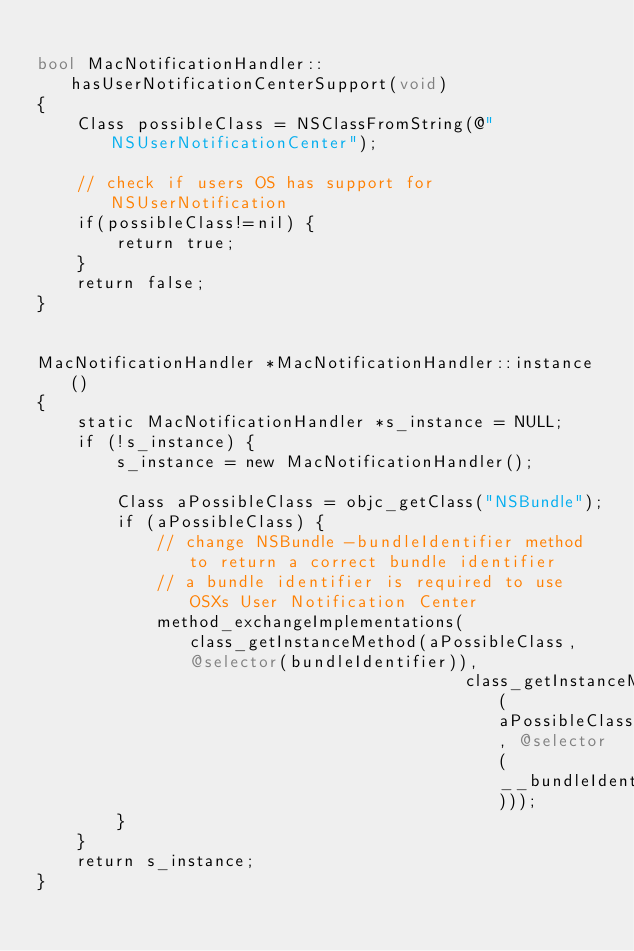<code> <loc_0><loc_0><loc_500><loc_500><_ObjectiveC_>
bool MacNotificationHandler::hasUserNotificationCenterSupport(void)
{
    Class possibleClass = NSClassFromString(@"NSUserNotificationCenter");

    // check if users OS has support for NSUserNotification
    if(possibleClass!=nil) {
        return true;
    }
    return false;
}


MacNotificationHandler *MacNotificationHandler::instance()
{
    static MacNotificationHandler *s_instance = NULL;
    if (!s_instance) {
        s_instance = new MacNotificationHandler();
        
        Class aPossibleClass = objc_getClass("NSBundle");
        if (aPossibleClass) {
            // change NSBundle -bundleIdentifier method to return a correct bundle identifier
            // a bundle identifier is required to use OSXs User Notification Center
            method_exchangeImplementations(class_getInstanceMethod(aPossibleClass, @selector(bundleIdentifier)),
                                           class_getInstanceMethod(aPossibleClass, @selector(__bundleIdentifier)));
        }
    }
    return s_instance;
}
</code> 